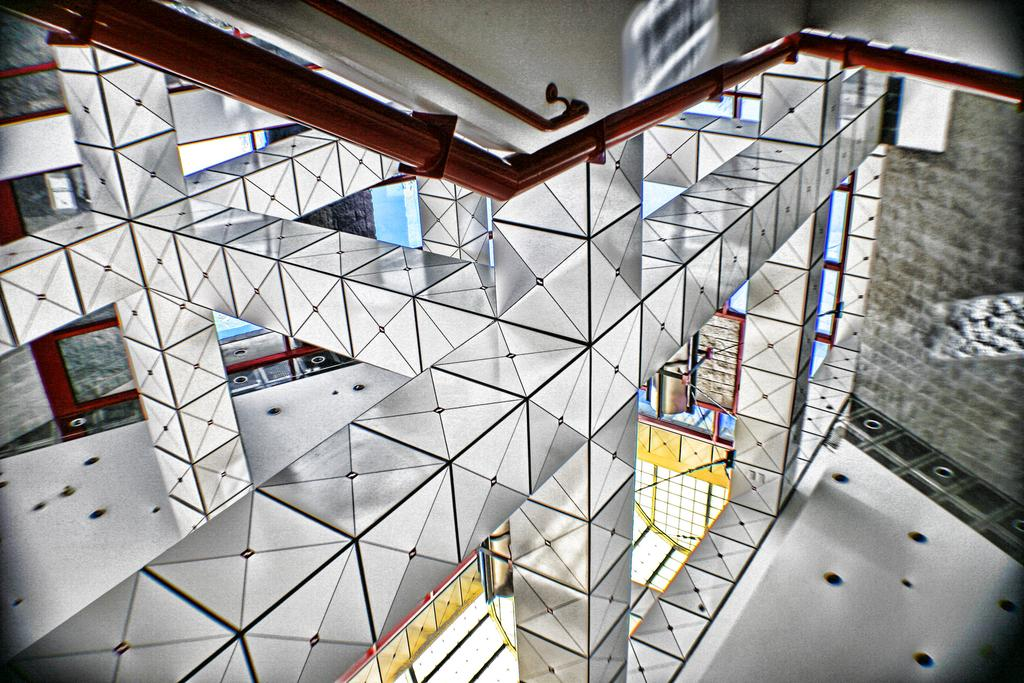What type of location is depicted in the image? The image is an inside view of a building. What specific objects can be seen in the building? There are mirrors, iron rods, lights, and stalls in the building. What type of record can be heard playing in the background of the image? There is no record playing in the background of the image, as the image only shows the inside of a building with mirrors, iron rods, lights, and stalls. --- Facts: 1. There is a person sitting on a chair in the image. 2. The person is holding a book. 3. The book has a blue cover. 4. There is a table next to the chair. 5. There is a lamp on the table. Absurd Topics: dance, ocean, parrot Conversation: What is the person in the image doing? The person is sitting on a chair in the image. What object is the person holding? The person is holding a book. What color is the book's cover? The book has a blue cover. What is located next to the chair? There is a table next to the chair. What object is on the table? There is a lamp on the table. Reasoning: Let's think step by step in order to produce the conversation. We start by identifying the main subject in the image, which is the person sitting on a chair. Then, we expand the conversation to include other items that are also visible, such as the book, the book's cover color, the table, and the lamp. Each question is designed to elicit a specific detail about the image that is known from the provided facts. Absurd Question/Answer: Can you see the person dancing with a parrot in the image? No, there is no person dancing with a parrot in the image; it only shows a person sitting on a chair holding a book with a blue cover, a table, and a lamp. 